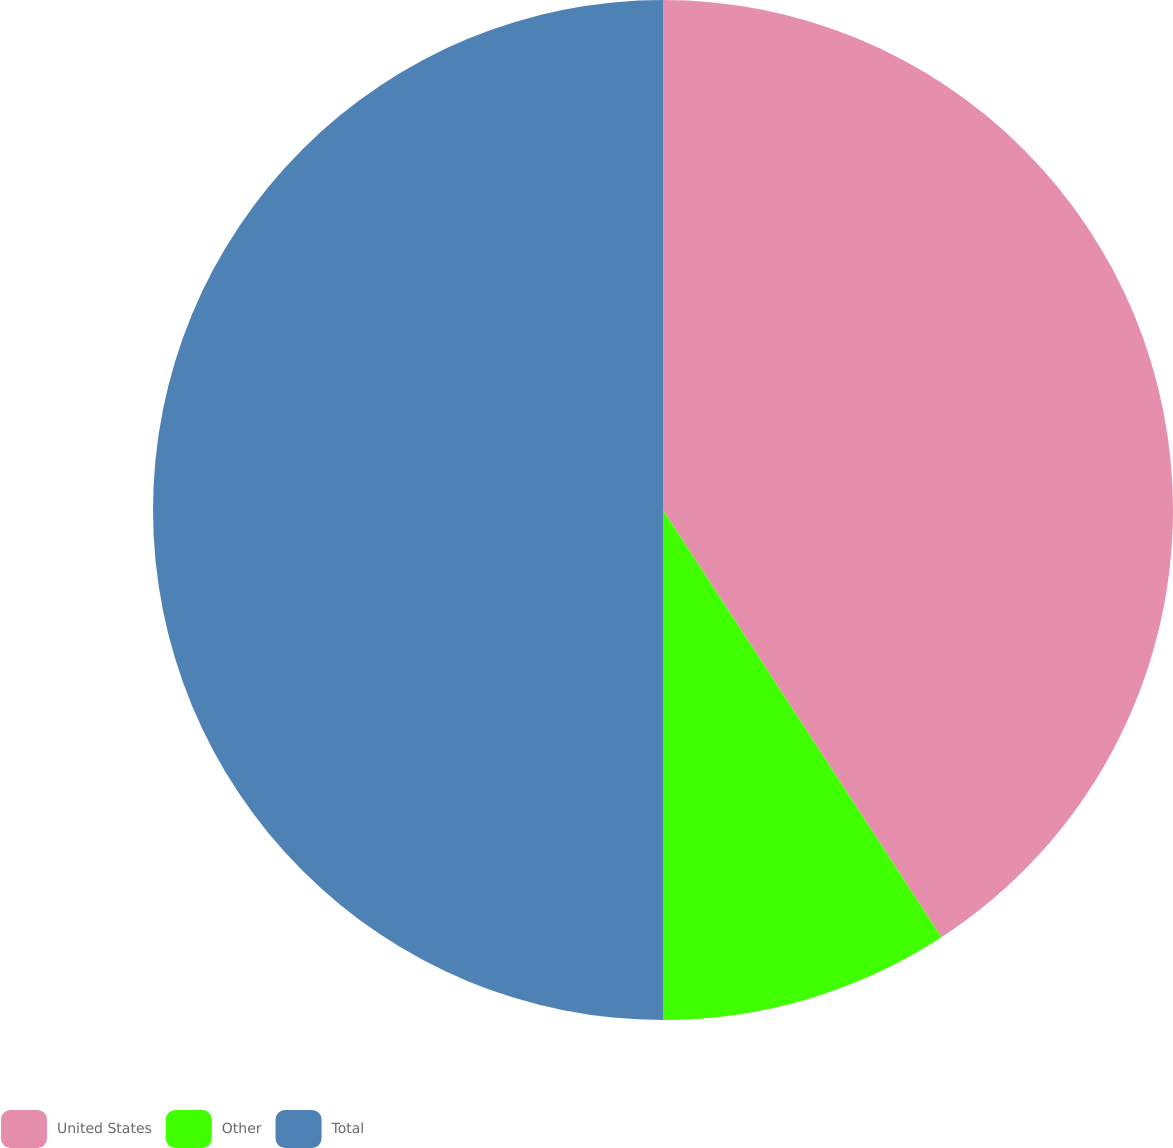Convert chart to OTSL. <chart><loc_0><loc_0><loc_500><loc_500><pie_chart><fcel>United States<fcel>Other<fcel>Total<nl><fcel>40.81%<fcel>9.19%<fcel>50.0%<nl></chart> 